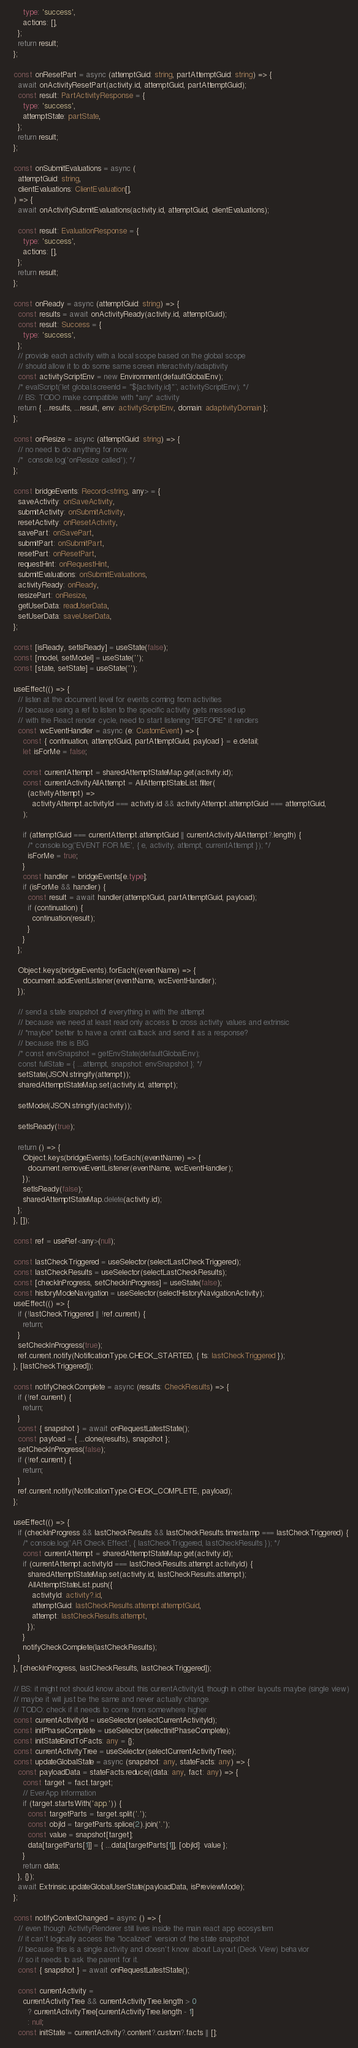<code> <loc_0><loc_0><loc_500><loc_500><_TypeScript_>      type: 'success',
      actions: [],
    };
    return result;
  };

  const onResetPart = async (attemptGuid: string, partAttemptGuid: string) => {
    await onActivityResetPart(activity.id, attemptGuid, partAttemptGuid);
    const result: PartActivityResponse = {
      type: 'success',
      attemptState: partState,
    };
    return result;
  };

  const onSubmitEvaluations = async (
    attemptGuid: string,
    clientEvaluations: ClientEvaluation[],
  ) => {
    await onActivitySubmitEvaluations(activity.id, attemptGuid, clientEvaluations);

    const result: EvaluationResponse = {
      type: 'success',
      actions: [],
    };
    return result;
  };

  const onReady = async (attemptGuid: string) => {
    const results = await onActivityReady(activity.id, attemptGuid);
    const result: Success = {
      type: 'success',
    };
    // provide each activity with a local scope based on the global scope
    // should allow it to do some same screen interactivity/adaptivity
    const activityScriptEnv = new Environment(defaultGlobalEnv);
    /* evalScript(`let global.screenId = "${activity.id}"`, activityScriptEnv); */
    // BS: TODO make compatible with *any* activity
    return { ...results, ...result, env: activityScriptEnv, domain: adaptivityDomain };
  };

  const onResize = async (attemptGuid: string) => {
    // no need to do anything for now.
    /*  console.log('onResize called'); */
  };

  const bridgeEvents: Record<string, any> = {
    saveActivity: onSaveActivity,
    submitActivity: onSubmitActivity,
    resetActivity: onResetActivity,
    savePart: onSavePart,
    submitPart: onSubmitPart,
    resetPart: onResetPart,
    requestHint: onRequestHint,
    submitEvaluations: onSubmitEvaluations,
    activityReady: onReady,
    resizePart: onResize,
    getUserData: readUserData,
    setUserData: saveUserData,
  };

  const [isReady, setIsReady] = useState(false);
  const [model, setModel] = useState('');
  const [state, setState] = useState('');

  useEffect(() => {
    // listen at the document level for events coming from activities
    // because using a ref to listen to the specific activity gets messed up
    // with the React render cycle, need to start listening *BEFORE* it renders
    const wcEventHandler = async (e: CustomEvent) => {
      const { continuation, attemptGuid, partAttemptGuid, payload } = e.detail;
      let isForMe = false;

      const currentAttempt = sharedAttemptStateMap.get(activity.id);
      const currentActivityAllAttempt = AllAttemptStateList.filter(
        (activityAttempt) =>
          activityAttempt.activityId === activity.id && activityAttempt.attemptGuid === attemptGuid,
      );

      if (attemptGuid === currentAttempt.attemptGuid || currentActivityAllAttempt?.length) {
        /* console.log('EVENT FOR ME', { e, activity, attempt, currentAttempt }); */
        isForMe = true;
      }
      const handler = bridgeEvents[e.type];
      if (isForMe && handler) {
        const result = await handler(attemptGuid, partAttemptGuid, payload);
        if (continuation) {
          continuation(result);
        }
      }
    };

    Object.keys(bridgeEvents).forEach((eventName) => {
      document.addEventListener(eventName, wcEventHandler);
    });

    // send a state snapshot of everything in with the attempt
    // because we need at least read only access to cross activity values and extrinsic
    // *maybe* better to have a onInit callback and send it as a response?
    // because this is BIG
    /* const envSnapshot = getEnvState(defaultGlobalEnv);
    const fullState = { ...attempt, snapshot: envSnapshot }; */
    setState(JSON.stringify(attempt));
    sharedAttemptStateMap.set(activity.id, attempt);

    setModel(JSON.stringify(activity));

    setIsReady(true);

    return () => {
      Object.keys(bridgeEvents).forEach((eventName) => {
        document.removeEventListener(eventName, wcEventHandler);
      });
      setIsReady(false);
      sharedAttemptStateMap.delete(activity.id);
    };
  }, []);

  const ref = useRef<any>(null);

  const lastCheckTriggered = useSelector(selectLastCheckTriggered);
  const lastCheckResults = useSelector(selectLastCheckResults);
  const [checkInProgress, setCheckInProgress] = useState(false);
  const historyModeNavigation = useSelector(selectHistoryNavigationActivity);
  useEffect(() => {
    if (!lastCheckTriggered || !ref.current) {
      return;
    }
    setCheckInProgress(true);
    ref.current.notify(NotificationType.CHECK_STARTED, { ts: lastCheckTriggered });
  }, [lastCheckTriggered]);

  const notifyCheckComplete = async (results: CheckResults) => {
    if (!ref.current) {
      return;
    }
    const { snapshot } = await onRequestLatestState();
    const payload = { ...clone(results), snapshot };
    setCheckInProgress(false);
    if (!ref.current) {
      return;
    }
    ref.current.notify(NotificationType.CHECK_COMPLETE, payload);
  };

  useEffect(() => {
    if (checkInProgress && lastCheckResults && lastCheckResults.timestamp === lastCheckTriggered) {
      /* console.log('AR Check Effect', { lastCheckTriggered, lastCheckResults }); */
      const currentAttempt = sharedAttemptStateMap.get(activity.id);
      if (currentAttempt.activityId === lastCheckResults.attempt.activityId) {
        sharedAttemptStateMap.set(activity.id, lastCheckResults.attempt);
        AllAttemptStateList.push({
          activityId: activity?.id,
          attemptGuid: lastCheckResults.attempt.attemptGuid,
          attempt: lastCheckResults.attempt,
        });
      }
      notifyCheckComplete(lastCheckResults);
    }
  }, [checkInProgress, lastCheckResults, lastCheckTriggered]);

  // BS: it might not should know about this currentActivityId, though in other layouts maybe (single view)
  // maybe it will just be the same and never actually change.
  // TODO: check if it needs to come from somewhere higher
  const currentActivityId = useSelector(selectCurrentActivityId);
  const initPhaseComplete = useSelector(selectInitPhaseComplete);
  const initStateBindToFacts: any = {};
  const currentActivityTree = useSelector(selectCurrentActivityTree);
  const updateGlobalState = async (snapshot: any, stateFacts: any) => {
    const payloadData = stateFacts.reduce((data: any, fact: any) => {
      const target = fact.target;
      // EverApp Information
      if (target.startsWith('app.')) {
        const targetParts = target.split('.');
        const objId = targetParts.splice(2).join('.');
        const value = snapshot[target];
        data[targetParts[1]] = { ...data[targetParts[1]], [objId]: value };
      }
      return data;
    }, {});
    await Extrinsic.updateGlobalUserState(payloadData, isPreviewMode);
  };

  const notifyContextChanged = async () => {
    // even though ActivityRenderer still lives inside the main react app ecosystem
    // it can't logically access the "localized" version of the state snapshot
    // because this is a single activity and doesn't know about Layout (Deck View) behavior
    // so it needs to ask the parent for it.
    const { snapshot } = await onRequestLatestState();

    const currentActivity =
      currentActivityTree && currentActivityTree.length > 0
        ? currentActivityTree[currentActivityTree.length - 1]
        : null;
    const initState = currentActivity?.content?.custom?.facts || [];
</code> 